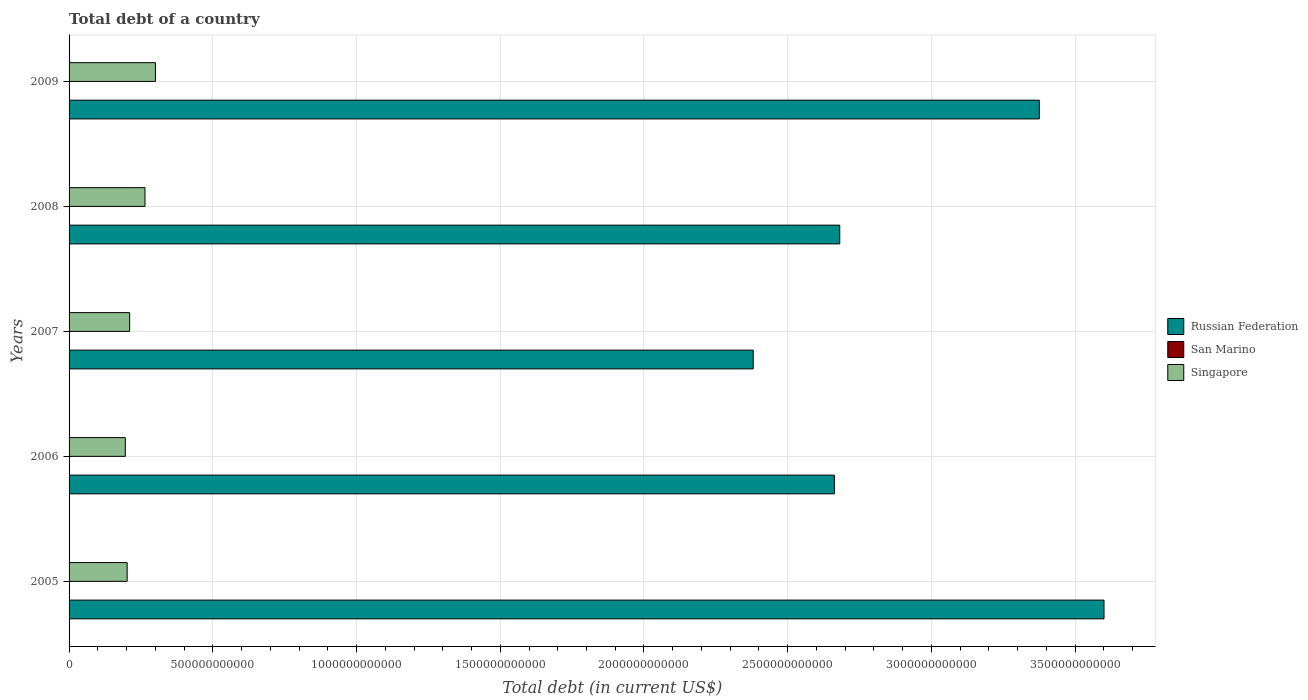How many different coloured bars are there?
Ensure brevity in your answer.  3. Are the number of bars on each tick of the Y-axis equal?
Your answer should be very brief. Yes. In how many cases, is the number of bars for a given year not equal to the number of legend labels?
Your answer should be compact. 0. What is the debt in Singapore in 2006?
Your answer should be very brief. 1.96e+11. Across all years, what is the maximum debt in San Marino?
Make the answer very short. 7.66e+08. Across all years, what is the minimum debt in Singapore?
Provide a succinct answer. 1.96e+11. In which year was the debt in San Marino maximum?
Offer a terse response. 2008. In which year was the debt in Singapore minimum?
Keep it short and to the point. 2006. What is the total debt in Singapore in the graph?
Offer a very short reply. 1.17e+12. What is the difference between the debt in Russian Federation in 2005 and that in 2008?
Your answer should be compact. 9.19e+11. What is the difference between the debt in Russian Federation in 2005 and the debt in San Marino in 2007?
Keep it short and to the point. 3.60e+12. What is the average debt in Singapore per year?
Your answer should be compact. 2.35e+11. In the year 2005, what is the difference between the debt in Russian Federation and debt in San Marino?
Offer a very short reply. 3.60e+12. In how many years, is the debt in Russian Federation greater than 3300000000000 US$?
Keep it short and to the point. 2. What is the ratio of the debt in Singapore in 2005 to that in 2006?
Your answer should be compact. 1.03. What is the difference between the highest and the second highest debt in San Marino?
Provide a succinct answer. 8.04e+06. What is the difference between the highest and the lowest debt in San Marino?
Keep it short and to the point. 2.01e+08. What does the 2nd bar from the top in 2006 represents?
Offer a terse response. San Marino. What does the 1st bar from the bottom in 2005 represents?
Provide a succinct answer. Russian Federation. Is it the case that in every year, the sum of the debt in Singapore and debt in Russian Federation is greater than the debt in San Marino?
Provide a succinct answer. Yes. How many bars are there?
Your answer should be compact. 15. Are all the bars in the graph horizontal?
Your answer should be compact. Yes. How many years are there in the graph?
Give a very brief answer. 5. What is the difference between two consecutive major ticks on the X-axis?
Give a very brief answer. 5.00e+11. What is the title of the graph?
Ensure brevity in your answer.  Total debt of a country. What is the label or title of the X-axis?
Your answer should be very brief. Total debt (in current US$). What is the label or title of the Y-axis?
Make the answer very short. Years. What is the Total debt (in current US$) of Russian Federation in 2005?
Offer a terse response. 3.60e+12. What is the Total debt (in current US$) of San Marino in 2005?
Give a very brief answer. 5.65e+08. What is the Total debt (in current US$) of Singapore in 2005?
Keep it short and to the point. 2.02e+11. What is the Total debt (in current US$) in Russian Federation in 2006?
Provide a short and direct response. 2.66e+12. What is the Total debt (in current US$) of San Marino in 2006?
Make the answer very short. 7.27e+08. What is the Total debt (in current US$) in Singapore in 2006?
Your answer should be very brief. 1.96e+11. What is the Total debt (in current US$) in Russian Federation in 2007?
Offer a very short reply. 2.38e+12. What is the Total debt (in current US$) of San Marino in 2007?
Provide a short and direct response. 7.58e+08. What is the Total debt (in current US$) of Singapore in 2007?
Your response must be concise. 2.11e+11. What is the Total debt (in current US$) in Russian Federation in 2008?
Provide a succinct answer. 2.68e+12. What is the Total debt (in current US$) of San Marino in 2008?
Offer a terse response. 7.66e+08. What is the Total debt (in current US$) in Singapore in 2008?
Offer a very short reply. 2.64e+11. What is the Total debt (in current US$) of Russian Federation in 2009?
Ensure brevity in your answer.  3.38e+12. What is the Total debt (in current US$) in San Marino in 2009?
Provide a succinct answer. 6.90e+08. What is the Total debt (in current US$) in Singapore in 2009?
Your response must be concise. 3.00e+11. Across all years, what is the maximum Total debt (in current US$) in Russian Federation?
Keep it short and to the point. 3.60e+12. Across all years, what is the maximum Total debt (in current US$) in San Marino?
Keep it short and to the point. 7.66e+08. Across all years, what is the maximum Total debt (in current US$) of Singapore?
Your response must be concise. 3.00e+11. Across all years, what is the minimum Total debt (in current US$) in Russian Federation?
Make the answer very short. 2.38e+12. Across all years, what is the minimum Total debt (in current US$) in San Marino?
Give a very brief answer. 5.65e+08. Across all years, what is the minimum Total debt (in current US$) in Singapore?
Your answer should be compact. 1.96e+11. What is the total Total debt (in current US$) in Russian Federation in the graph?
Your answer should be very brief. 1.47e+13. What is the total Total debt (in current US$) in San Marino in the graph?
Offer a very short reply. 3.50e+09. What is the total Total debt (in current US$) of Singapore in the graph?
Give a very brief answer. 1.17e+12. What is the difference between the Total debt (in current US$) of Russian Federation in 2005 and that in 2006?
Provide a short and direct response. 9.38e+11. What is the difference between the Total debt (in current US$) of San Marino in 2005 and that in 2006?
Offer a very short reply. -1.62e+08. What is the difference between the Total debt (in current US$) of Singapore in 2005 and that in 2006?
Provide a succinct answer. 6.39e+09. What is the difference between the Total debt (in current US$) in Russian Federation in 2005 and that in 2007?
Offer a terse response. 1.22e+12. What is the difference between the Total debt (in current US$) of San Marino in 2005 and that in 2007?
Keep it short and to the point. -1.93e+08. What is the difference between the Total debt (in current US$) of Singapore in 2005 and that in 2007?
Offer a terse response. -8.71e+09. What is the difference between the Total debt (in current US$) in Russian Federation in 2005 and that in 2008?
Ensure brevity in your answer.  9.19e+11. What is the difference between the Total debt (in current US$) in San Marino in 2005 and that in 2008?
Offer a terse response. -2.01e+08. What is the difference between the Total debt (in current US$) of Singapore in 2005 and that in 2008?
Provide a succinct answer. -6.21e+1. What is the difference between the Total debt (in current US$) in Russian Federation in 2005 and that in 2009?
Your answer should be very brief. 2.25e+11. What is the difference between the Total debt (in current US$) of San Marino in 2005 and that in 2009?
Give a very brief answer. -1.25e+08. What is the difference between the Total debt (in current US$) of Singapore in 2005 and that in 2009?
Ensure brevity in your answer.  -9.84e+1. What is the difference between the Total debt (in current US$) in Russian Federation in 2006 and that in 2007?
Your answer should be compact. 2.82e+11. What is the difference between the Total debt (in current US$) in San Marino in 2006 and that in 2007?
Your answer should be compact. -3.13e+07. What is the difference between the Total debt (in current US$) in Singapore in 2006 and that in 2007?
Your answer should be very brief. -1.51e+1. What is the difference between the Total debt (in current US$) in Russian Federation in 2006 and that in 2008?
Your response must be concise. -1.87e+1. What is the difference between the Total debt (in current US$) in San Marino in 2006 and that in 2008?
Keep it short and to the point. -3.93e+07. What is the difference between the Total debt (in current US$) of Singapore in 2006 and that in 2008?
Offer a terse response. -6.85e+1. What is the difference between the Total debt (in current US$) of Russian Federation in 2006 and that in 2009?
Your response must be concise. -7.13e+11. What is the difference between the Total debt (in current US$) of San Marino in 2006 and that in 2009?
Make the answer very short. 3.67e+07. What is the difference between the Total debt (in current US$) of Singapore in 2006 and that in 2009?
Offer a terse response. -1.05e+11. What is the difference between the Total debt (in current US$) in Russian Federation in 2007 and that in 2008?
Give a very brief answer. -3.01e+11. What is the difference between the Total debt (in current US$) in San Marino in 2007 and that in 2008?
Give a very brief answer. -8.04e+06. What is the difference between the Total debt (in current US$) in Singapore in 2007 and that in 2008?
Your response must be concise. -5.34e+1. What is the difference between the Total debt (in current US$) of Russian Federation in 2007 and that in 2009?
Keep it short and to the point. -9.95e+11. What is the difference between the Total debt (in current US$) of San Marino in 2007 and that in 2009?
Provide a short and direct response. 6.80e+07. What is the difference between the Total debt (in current US$) of Singapore in 2007 and that in 2009?
Provide a short and direct response. -8.97e+1. What is the difference between the Total debt (in current US$) in Russian Federation in 2008 and that in 2009?
Provide a short and direct response. -6.94e+11. What is the difference between the Total debt (in current US$) in San Marino in 2008 and that in 2009?
Keep it short and to the point. 7.60e+07. What is the difference between the Total debt (in current US$) in Singapore in 2008 and that in 2009?
Ensure brevity in your answer.  -3.63e+1. What is the difference between the Total debt (in current US$) in Russian Federation in 2005 and the Total debt (in current US$) in San Marino in 2006?
Ensure brevity in your answer.  3.60e+12. What is the difference between the Total debt (in current US$) in Russian Federation in 2005 and the Total debt (in current US$) in Singapore in 2006?
Provide a succinct answer. 3.40e+12. What is the difference between the Total debt (in current US$) in San Marino in 2005 and the Total debt (in current US$) in Singapore in 2006?
Give a very brief answer. -1.95e+11. What is the difference between the Total debt (in current US$) in Russian Federation in 2005 and the Total debt (in current US$) in San Marino in 2007?
Your answer should be very brief. 3.60e+12. What is the difference between the Total debt (in current US$) in Russian Federation in 2005 and the Total debt (in current US$) in Singapore in 2007?
Ensure brevity in your answer.  3.39e+12. What is the difference between the Total debt (in current US$) in San Marino in 2005 and the Total debt (in current US$) in Singapore in 2007?
Your answer should be compact. -2.10e+11. What is the difference between the Total debt (in current US$) in Russian Federation in 2005 and the Total debt (in current US$) in San Marino in 2008?
Ensure brevity in your answer.  3.60e+12. What is the difference between the Total debt (in current US$) in Russian Federation in 2005 and the Total debt (in current US$) in Singapore in 2008?
Ensure brevity in your answer.  3.34e+12. What is the difference between the Total debt (in current US$) of San Marino in 2005 and the Total debt (in current US$) of Singapore in 2008?
Your response must be concise. -2.64e+11. What is the difference between the Total debt (in current US$) of Russian Federation in 2005 and the Total debt (in current US$) of San Marino in 2009?
Ensure brevity in your answer.  3.60e+12. What is the difference between the Total debt (in current US$) of Russian Federation in 2005 and the Total debt (in current US$) of Singapore in 2009?
Offer a terse response. 3.30e+12. What is the difference between the Total debt (in current US$) in San Marino in 2005 and the Total debt (in current US$) in Singapore in 2009?
Ensure brevity in your answer.  -3.00e+11. What is the difference between the Total debt (in current US$) in Russian Federation in 2006 and the Total debt (in current US$) in San Marino in 2007?
Provide a short and direct response. 2.66e+12. What is the difference between the Total debt (in current US$) in Russian Federation in 2006 and the Total debt (in current US$) in Singapore in 2007?
Offer a terse response. 2.45e+12. What is the difference between the Total debt (in current US$) of San Marino in 2006 and the Total debt (in current US$) of Singapore in 2007?
Give a very brief answer. -2.10e+11. What is the difference between the Total debt (in current US$) of Russian Federation in 2006 and the Total debt (in current US$) of San Marino in 2008?
Offer a very short reply. 2.66e+12. What is the difference between the Total debt (in current US$) in Russian Federation in 2006 and the Total debt (in current US$) in Singapore in 2008?
Ensure brevity in your answer.  2.40e+12. What is the difference between the Total debt (in current US$) in San Marino in 2006 and the Total debt (in current US$) in Singapore in 2008?
Provide a succinct answer. -2.63e+11. What is the difference between the Total debt (in current US$) in Russian Federation in 2006 and the Total debt (in current US$) in San Marino in 2009?
Your answer should be very brief. 2.66e+12. What is the difference between the Total debt (in current US$) of Russian Federation in 2006 and the Total debt (in current US$) of Singapore in 2009?
Make the answer very short. 2.36e+12. What is the difference between the Total debt (in current US$) in San Marino in 2006 and the Total debt (in current US$) in Singapore in 2009?
Your answer should be compact. -3.00e+11. What is the difference between the Total debt (in current US$) in Russian Federation in 2007 and the Total debt (in current US$) in San Marino in 2008?
Offer a very short reply. 2.38e+12. What is the difference between the Total debt (in current US$) of Russian Federation in 2007 and the Total debt (in current US$) of Singapore in 2008?
Your answer should be very brief. 2.12e+12. What is the difference between the Total debt (in current US$) in San Marino in 2007 and the Total debt (in current US$) in Singapore in 2008?
Your answer should be very brief. -2.63e+11. What is the difference between the Total debt (in current US$) of Russian Federation in 2007 and the Total debt (in current US$) of San Marino in 2009?
Your answer should be compact. 2.38e+12. What is the difference between the Total debt (in current US$) of Russian Federation in 2007 and the Total debt (in current US$) of Singapore in 2009?
Offer a very short reply. 2.08e+12. What is the difference between the Total debt (in current US$) in San Marino in 2007 and the Total debt (in current US$) in Singapore in 2009?
Offer a very short reply. -3.00e+11. What is the difference between the Total debt (in current US$) of Russian Federation in 2008 and the Total debt (in current US$) of San Marino in 2009?
Provide a succinct answer. 2.68e+12. What is the difference between the Total debt (in current US$) of Russian Federation in 2008 and the Total debt (in current US$) of Singapore in 2009?
Give a very brief answer. 2.38e+12. What is the difference between the Total debt (in current US$) in San Marino in 2008 and the Total debt (in current US$) in Singapore in 2009?
Make the answer very short. -3.00e+11. What is the average Total debt (in current US$) of Russian Federation per year?
Provide a short and direct response. 2.94e+12. What is the average Total debt (in current US$) of San Marino per year?
Your answer should be compact. 7.01e+08. What is the average Total debt (in current US$) in Singapore per year?
Your answer should be compact. 2.35e+11. In the year 2005, what is the difference between the Total debt (in current US$) of Russian Federation and Total debt (in current US$) of San Marino?
Your answer should be compact. 3.60e+12. In the year 2005, what is the difference between the Total debt (in current US$) in Russian Federation and Total debt (in current US$) in Singapore?
Keep it short and to the point. 3.40e+12. In the year 2005, what is the difference between the Total debt (in current US$) in San Marino and Total debt (in current US$) in Singapore?
Make the answer very short. -2.01e+11. In the year 2006, what is the difference between the Total debt (in current US$) in Russian Federation and Total debt (in current US$) in San Marino?
Ensure brevity in your answer.  2.66e+12. In the year 2006, what is the difference between the Total debt (in current US$) of Russian Federation and Total debt (in current US$) of Singapore?
Keep it short and to the point. 2.47e+12. In the year 2006, what is the difference between the Total debt (in current US$) of San Marino and Total debt (in current US$) of Singapore?
Make the answer very short. -1.95e+11. In the year 2007, what is the difference between the Total debt (in current US$) of Russian Federation and Total debt (in current US$) of San Marino?
Offer a very short reply. 2.38e+12. In the year 2007, what is the difference between the Total debt (in current US$) of Russian Federation and Total debt (in current US$) of Singapore?
Ensure brevity in your answer.  2.17e+12. In the year 2007, what is the difference between the Total debt (in current US$) of San Marino and Total debt (in current US$) of Singapore?
Provide a short and direct response. -2.10e+11. In the year 2008, what is the difference between the Total debt (in current US$) in Russian Federation and Total debt (in current US$) in San Marino?
Give a very brief answer. 2.68e+12. In the year 2008, what is the difference between the Total debt (in current US$) of Russian Federation and Total debt (in current US$) of Singapore?
Make the answer very short. 2.42e+12. In the year 2008, what is the difference between the Total debt (in current US$) in San Marino and Total debt (in current US$) in Singapore?
Your answer should be very brief. -2.63e+11. In the year 2009, what is the difference between the Total debt (in current US$) in Russian Federation and Total debt (in current US$) in San Marino?
Offer a terse response. 3.37e+12. In the year 2009, what is the difference between the Total debt (in current US$) of Russian Federation and Total debt (in current US$) of Singapore?
Your response must be concise. 3.08e+12. In the year 2009, what is the difference between the Total debt (in current US$) of San Marino and Total debt (in current US$) of Singapore?
Your response must be concise. -3.00e+11. What is the ratio of the Total debt (in current US$) of Russian Federation in 2005 to that in 2006?
Offer a terse response. 1.35. What is the ratio of the Total debt (in current US$) of San Marino in 2005 to that in 2006?
Provide a succinct answer. 0.78. What is the ratio of the Total debt (in current US$) in Singapore in 2005 to that in 2006?
Keep it short and to the point. 1.03. What is the ratio of the Total debt (in current US$) of Russian Federation in 2005 to that in 2007?
Your answer should be compact. 1.51. What is the ratio of the Total debt (in current US$) of San Marino in 2005 to that in 2007?
Your answer should be very brief. 0.75. What is the ratio of the Total debt (in current US$) of Singapore in 2005 to that in 2007?
Provide a succinct answer. 0.96. What is the ratio of the Total debt (in current US$) in Russian Federation in 2005 to that in 2008?
Give a very brief answer. 1.34. What is the ratio of the Total debt (in current US$) of San Marino in 2005 to that in 2008?
Provide a succinct answer. 0.74. What is the ratio of the Total debt (in current US$) of Singapore in 2005 to that in 2008?
Give a very brief answer. 0.76. What is the ratio of the Total debt (in current US$) of Russian Federation in 2005 to that in 2009?
Your answer should be compact. 1.07. What is the ratio of the Total debt (in current US$) of San Marino in 2005 to that in 2009?
Give a very brief answer. 0.82. What is the ratio of the Total debt (in current US$) of Singapore in 2005 to that in 2009?
Your answer should be very brief. 0.67. What is the ratio of the Total debt (in current US$) in Russian Federation in 2006 to that in 2007?
Ensure brevity in your answer.  1.12. What is the ratio of the Total debt (in current US$) of San Marino in 2006 to that in 2007?
Give a very brief answer. 0.96. What is the ratio of the Total debt (in current US$) in Singapore in 2006 to that in 2007?
Offer a very short reply. 0.93. What is the ratio of the Total debt (in current US$) of Russian Federation in 2006 to that in 2008?
Your answer should be very brief. 0.99. What is the ratio of the Total debt (in current US$) of San Marino in 2006 to that in 2008?
Your answer should be compact. 0.95. What is the ratio of the Total debt (in current US$) in Singapore in 2006 to that in 2008?
Keep it short and to the point. 0.74. What is the ratio of the Total debt (in current US$) of Russian Federation in 2006 to that in 2009?
Ensure brevity in your answer.  0.79. What is the ratio of the Total debt (in current US$) in San Marino in 2006 to that in 2009?
Provide a short and direct response. 1.05. What is the ratio of the Total debt (in current US$) of Singapore in 2006 to that in 2009?
Give a very brief answer. 0.65. What is the ratio of the Total debt (in current US$) of Russian Federation in 2007 to that in 2008?
Your answer should be very brief. 0.89. What is the ratio of the Total debt (in current US$) in San Marino in 2007 to that in 2008?
Provide a short and direct response. 0.99. What is the ratio of the Total debt (in current US$) in Singapore in 2007 to that in 2008?
Your response must be concise. 0.8. What is the ratio of the Total debt (in current US$) of Russian Federation in 2007 to that in 2009?
Provide a succinct answer. 0.71. What is the ratio of the Total debt (in current US$) of San Marino in 2007 to that in 2009?
Give a very brief answer. 1.1. What is the ratio of the Total debt (in current US$) of Singapore in 2007 to that in 2009?
Give a very brief answer. 0.7. What is the ratio of the Total debt (in current US$) of Russian Federation in 2008 to that in 2009?
Your answer should be very brief. 0.79. What is the ratio of the Total debt (in current US$) of San Marino in 2008 to that in 2009?
Keep it short and to the point. 1.11. What is the ratio of the Total debt (in current US$) of Singapore in 2008 to that in 2009?
Offer a terse response. 0.88. What is the difference between the highest and the second highest Total debt (in current US$) in Russian Federation?
Your response must be concise. 2.25e+11. What is the difference between the highest and the second highest Total debt (in current US$) of San Marino?
Provide a short and direct response. 8.04e+06. What is the difference between the highest and the second highest Total debt (in current US$) in Singapore?
Ensure brevity in your answer.  3.63e+1. What is the difference between the highest and the lowest Total debt (in current US$) of Russian Federation?
Ensure brevity in your answer.  1.22e+12. What is the difference between the highest and the lowest Total debt (in current US$) in San Marino?
Give a very brief answer. 2.01e+08. What is the difference between the highest and the lowest Total debt (in current US$) of Singapore?
Make the answer very short. 1.05e+11. 